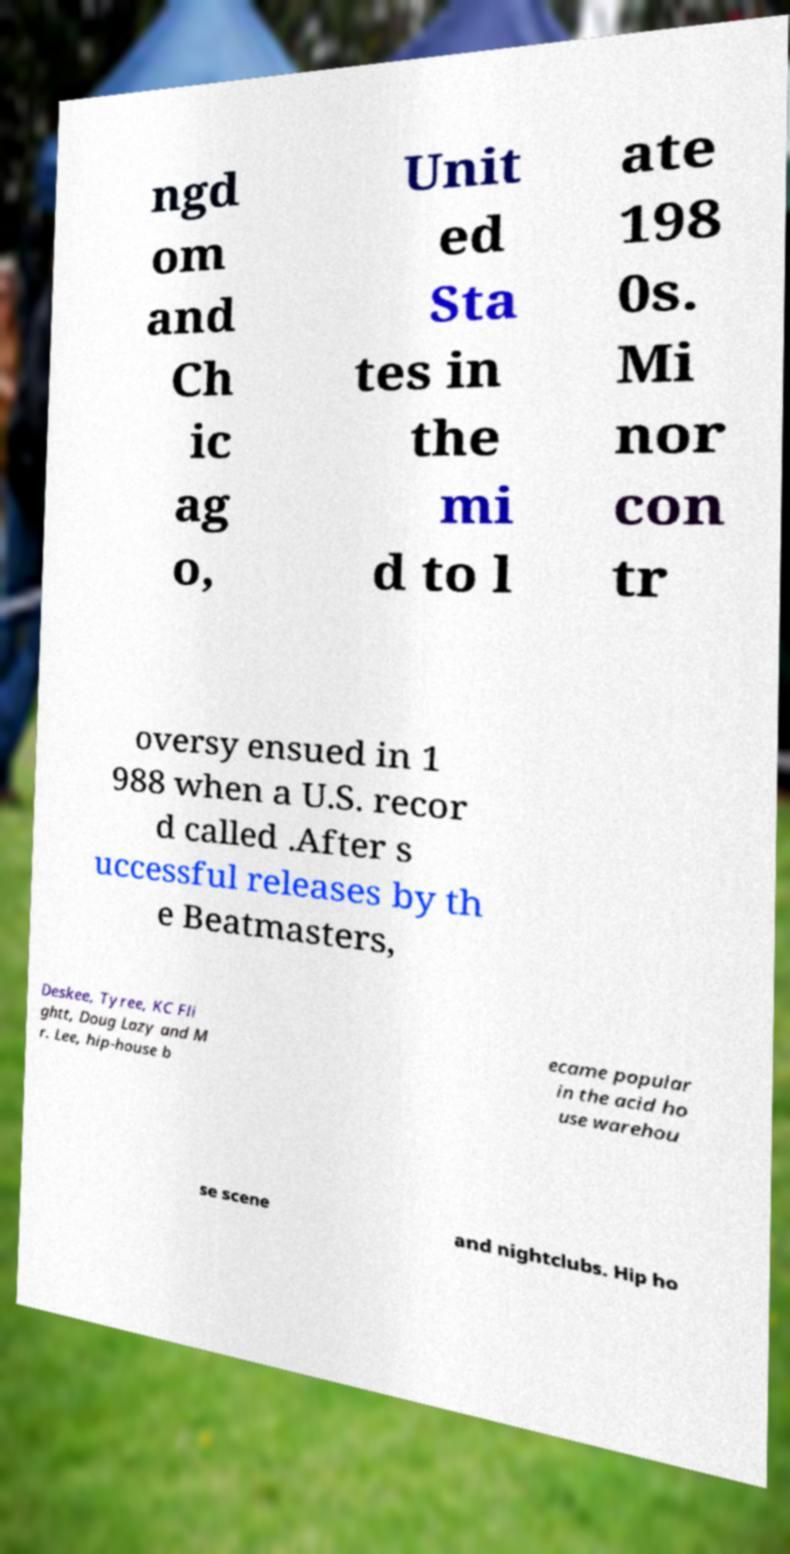Please read and relay the text visible in this image. What does it say? ngd om and Ch ic ag o, Unit ed Sta tes in the mi d to l ate 198 0s. Mi nor con tr oversy ensued in 1 988 when a U.S. recor d called .After s uccessful releases by th e Beatmasters, Deskee, Tyree, KC Fli ghtt, Doug Lazy and M r. Lee, hip-house b ecame popular in the acid ho use warehou se scene and nightclubs. Hip ho 